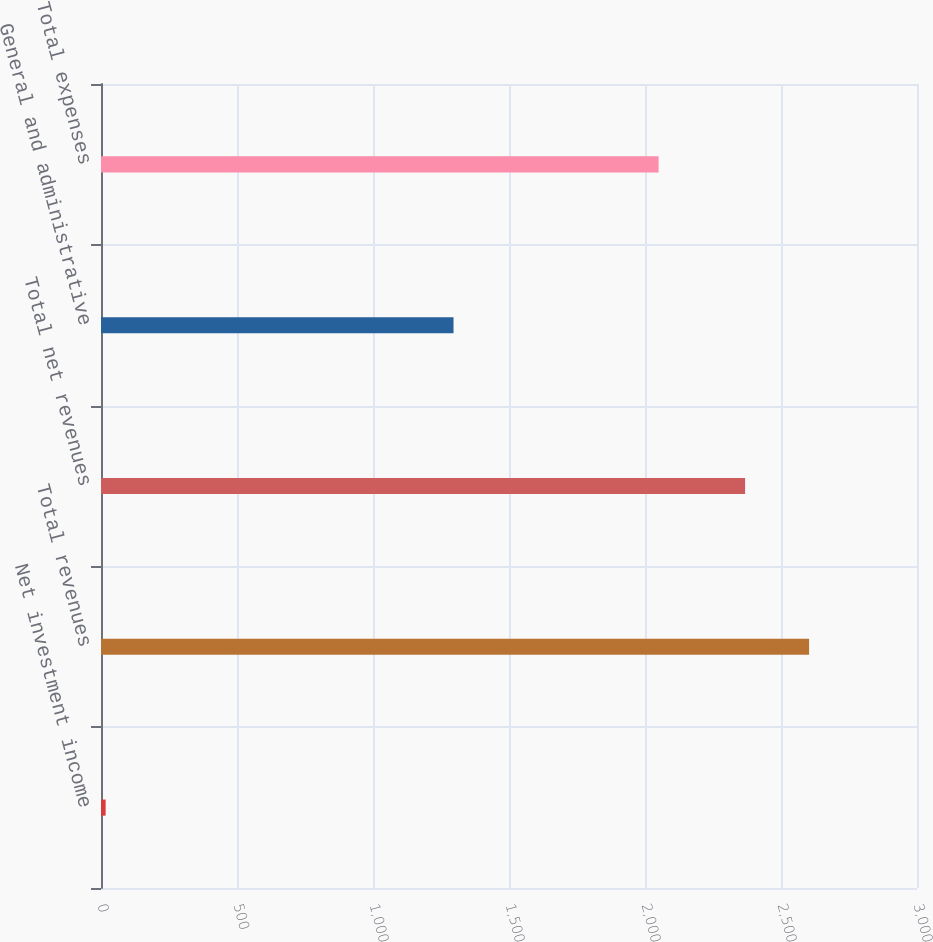Convert chart. <chart><loc_0><loc_0><loc_500><loc_500><bar_chart><fcel>Net investment income<fcel>Total revenues<fcel>Total net revenues<fcel>General and administrative<fcel>Total expenses<nl><fcel>17<fcel>2603.2<fcel>2368<fcel>1296<fcel>2050<nl></chart> 